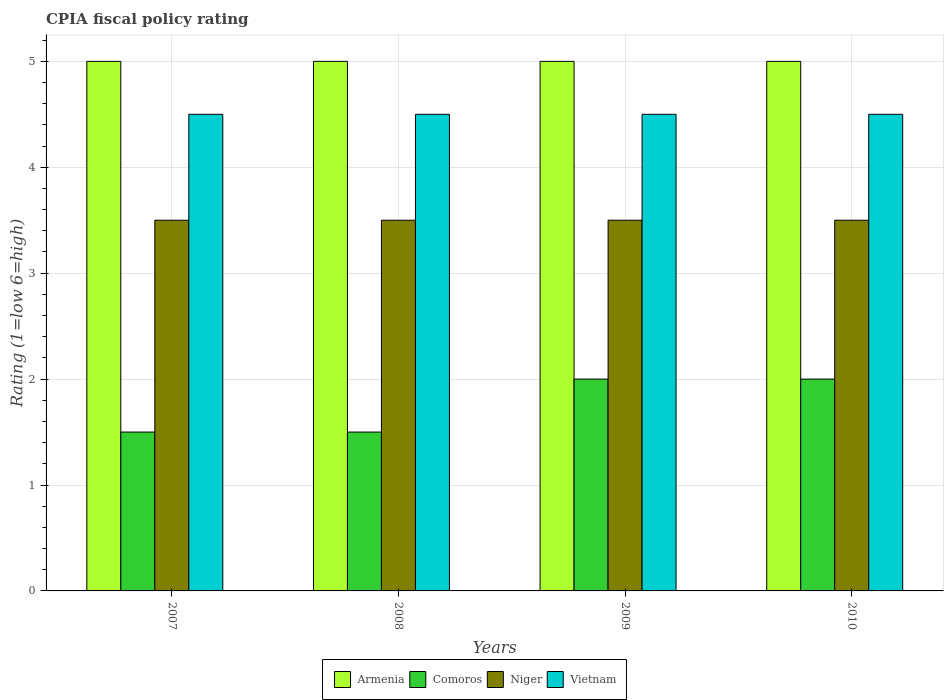Are the number of bars per tick equal to the number of legend labels?
Your answer should be compact. Yes. How many bars are there on the 1st tick from the right?
Provide a succinct answer. 4. What is the label of the 3rd group of bars from the left?
Offer a terse response. 2009. In how many cases, is the number of bars for a given year not equal to the number of legend labels?
Offer a terse response. 0. Across all years, what is the minimum CPIA rating in Niger?
Make the answer very short. 3.5. In which year was the CPIA rating in Niger maximum?
Give a very brief answer. 2007. What is the difference between the CPIA rating in Vietnam in 2007 and that in 2008?
Keep it short and to the point. 0. What is the difference between the CPIA rating in Armenia in 2007 and the CPIA rating in Comoros in 2010?
Keep it short and to the point. 3. In the year 2008, what is the difference between the CPIA rating in Armenia and CPIA rating in Vietnam?
Your answer should be compact. 0.5. In how many years, is the CPIA rating in Vietnam greater than 2.6?
Give a very brief answer. 4. What is the ratio of the CPIA rating in Vietnam in 2009 to that in 2010?
Provide a short and direct response. 1. Is the CPIA rating in Armenia in 2007 less than that in 2010?
Provide a short and direct response. No. Is the difference between the CPIA rating in Armenia in 2007 and 2008 greater than the difference between the CPIA rating in Vietnam in 2007 and 2008?
Offer a terse response. No. What is the difference between the highest and the lowest CPIA rating in Comoros?
Your answer should be very brief. 0.5. In how many years, is the CPIA rating in Armenia greater than the average CPIA rating in Armenia taken over all years?
Provide a short and direct response. 0. Is the sum of the CPIA rating in Niger in 2007 and 2008 greater than the maximum CPIA rating in Armenia across all years?
Your response must be concise. Yes. Is it the case that in every year, the sum of the CPIA rating in Armenia and CPIA rating in Vietnam is greater than the sum of CPIA rating in Comoros and CPIA rating in Niger?
Your answer should be compact. Yes. What does the 1st bar from the left in 2010 represents?
Your response must be concise. Armenia. What does the 3rd bar from the right in 2010 represents?
Give a very brief answer. Comoros. Is it the case that in every year, the sum of the CPIA rating in Vietnam and CPIA rating in Armenia is greater than the CPIA rating in Comoros?
Provide a short and direct response. Yes. How many bars are there?
Give a very brief answer. 16. Are all the bars in the graph horizontal?
Offer a very short reply. No. How many years are there in the graph?
Your response must be concise. 4. What is the difference between two consecutive major ticks on the Y-axis?
Keep it short and to the point. 1. Does the graph contain any zero values?
Your answer should be compact. No. Does the graph contain grids?
Your response must be concise. Yes. How are the legend labels stacked?
Provide a short and direct response. Horizontal. What is the title of the graph?
Your answer should be very brief. CPIA fiscal policy rating. Does "Malta" appear as one of the legend labels in the graph?
Give a very brief answer. No. What is the Rating (1=low 6=high) of Niger in 2007?
Offer a terse response. 3.5. What is the Rating (1=low 6=high) in Niger in 2008?
Make the answer very short. 3.5. What is the Rating (1=low 6=high) in Vietnam in 2008?
Give a very brief answer. 4.5. What is the Rating (1=low 6=high) of Armenia in 2009?
Provide a succinct answer. 5. What is the Rating (1=low 6=high) of Niger in 2009?
Your response must be concise. 3.5. What is the Rating (1=low 6=high) of Armenia in 2010?
Offer a terse response. 5. Across all years, what is the maximum Rating (1=low 6=high) in Armenia?
Give a very brief answer. 5. Across all years, what is the maximum Rating (1=low 6=high) in Vietnam?
Ensure brevity in your answer.  4.5. What is the total Rating (1=low 6=high) of Niger in the graph?
Your answer should be compact. 14. What is the total Rating (1=low 6=high) of Vietnam in the graph?
Your answer should be compact. 18. What is the difference between the Rating (1=low 6=high) in Armenia in 2007 and that in 2008?
Ensure brevity in your answer.  0. What is the difference between the Rating (1=low 6=high) in Armenia in 2007 and that in 2009?
Your answer should be very brief. 0. What is the difference between the Rating (1=low 6=high) of Comoros in 2007 and that in 2010?
Provide a short and direct response. -0.5. What is the difference between the Rating (1=low 6=high) of Vietnam in 2007 and that in 2010?
Provide a short and direct response. 0. What is the difference between the Rating (1=low 6=high) of Comoros in 2008 and that in 2009?
Make the answer very short. -0.5. What is the difference between the Rating (1=low 6=high) of Niger in 2008 and that in 2009?
Make the answer very short. 0. What is the difference between the Rating (1=low 6=high) of Vietnam in 2008 and that in 2009?
Provide a succinct answer. 0. What is the difference between the Rating (1=low 6=high) of Armenia in 2008 and that in 2010?
Offer a terse response. 0. What is the difference between the Rating (1=low 6=high) in Niger in 2008 and that in 2010?
Give a very brief answer. 0. What is the difference between the Rating (1=low 6=high) of Comoros in 2009 and that in 2010?
Your answer should be very brief. 0. What is the difference between the Rating (1=low 6=high) in Niger in 2009 and that in 2010?
Ensure brevity in your answer.  0. What is the difference between the Rating (1=low 6=high) of Vietnam in 2009 and that in 2010?
Provide a short and direct response. 0. What is the difference between the Rating (1=low 6=high) of Armenia in 2007 and the Rating (1=low 6=high) of Comoros in 2008?
Give a very brief answer. 3.5. What is the difference between the Rating (1=low 6=high) in Armenia in 2007 and the Rating (1=low 6=high) in Vietnam in 2008?
Provide a short and direct response. 0.5. What is the difference between the Rating (1=low 6=high) of Comoros in 2007 and the Rating (1=low 6=high) of Niger in 2008?
Provide a succinct answer. -2. What is the difference between the Rating (1=low 6=high) in Comoros in 2007 and the Rating (1=low 6=high) in Vietnam in 2008?
Offer a very short reply. -3. What is the difference between the Rating (1=low 6=high) of Armenia in 2007 and the Rating (1=low 6=high) of Vietnam in 2009?
Your response must be concise. 0.5. What is the difference between the Rating (1=low 6=high) of Comoros in 2007 and the Rating (1=low 6=high) of Vietnam in 2009?
Ensure brevity in your answer.  -3. What is the difference between the Rating (1=low 6=high) of Armenia in 2007 and the Rating (1=low 6=high) of Comoros in 2010?
Ensure brevity in your answer.  3. What is the difference between the Rating (1=low 6=high) in Comoros in 2007 and the Rating (1=low 6=high) in Niger in 2010?
Keep it short and to the point. -2. What is the difference between the Rating (1=low 6=high) of Armenia in 2008 and the Rating (1=low 6=high) of Comoros in 2009?
Provide a succinct answer. 3. What is the difference between the Rating (1=low 6=high) of Niger in 2008 and the Rating (1=low 6=high) of Vietnam in 2009?
Your response must be concise. -1. What is the difference between the Rating (1=low 6=high) of Comoros in 2008 and the Rating (1=low 6=high) of Niger in 2010?
Give a very brief answer. -2. What is the difference between the Rating (1=low 6=high) in Niger in 2008 and the Rating (1=low 6=high) in Vietnam in 2010?
Your response must be concise. -1. What is the difference between the Rating (1=low 6=high) of Armenia in 2009 and the Rating (1=low 6=high) of Niger in 2010?
Your answer should be very brief. 1.5. What is the difference between the Rating (1=low 6=high) of Armenia in 2009 and the Rating (1=low 6=high) of Vietnam in 2010?
Your answer should be compact. 0.5. What is the difference between the Rating (1=low 6=high) in Comoros in 2009 and the Rating (1=low 6=high) in Niger in 2010?
Your response must be concise. -1.5. What is the difference between the Rating (1=low 6=high) of Comoros in 2009 and the Rating (1=low 6=high) of Vietnam in 2010?
Your answer should be compact. -2.5. What is the average Rating (1=low 6=high) in Armenia per year?
Your answer should be compact. 5. In the year 2007, what is the difference between the Rating (1=low 6=high) of Armenia and Rating (1=low 6=high) of Niger?
Provide a short and direct response. 1.5. In the year 2007, what is the difference between the Rating (1=low 6=high) of Comoros and Rating (1=low 6=high) of Niger?
Give a very brief answer. -2. In the year 2007, what is the difference between the Rating (1=low 6=high) of Comoros and Rating (1=low 6=high) of Vietnam?
Ensure brevity in your answer.  -3. In the year 2007, what is the difference between the Rating (1=low 6=high) of Niger and Rating (1=low 6=high) of Vietnam?
Ensure brevity in your answer.  -1. In the year 2008, what is the difference between the Rating (1=low 6=high) in Armenia and Rating (1=low 6=high) in Comoros?
Your response must be concise. 3.5. In the year 2008, what is the difference between the Rating (1=low 6=high) in Armenia and Rating (1=low 6=high) in Vietnam?
Provide a succinct answer. 0.5. In the year 2008, what is the difference between the Rating (1=low 6=high) of Comoros and Rating (1=low 6=high) of Niger?
Ensure brevity in your answer.  -2. In the year 2008, what is the difference between the Rating (1=low 6=high) in Comoros and Rating (1=low 6=high) in Vietnam?
Offer a very short reply. -3. In the year 2008, what is the difference between the Rating (1=low 6=high) in Niger and Rating (1=low 6=high) in Vietnam?
Provide a short and direct response. -1. In the year 2009, what is the difference between the Rating (1=low 6=high) in Armenia and Rating (1=low 6=high) in Comoros?
Offer a very short reply. 3. In the year 2009, what is the difference between the Rating (1=low 6=high) in Comoros and Rating (1=low 6=high) in Niger?
Provide a short and direct response. -1.5. In the year 2010, what is the difference between the Rating (1=low 6=high) in Armenia and Rating (1=low 6=high) in Niger?
Offer a very short reply. 1.5. In the year 2010, what is the difference between the Rating (1=low 6=high) in Comoros and Rating (1=low 6=high) in Niger?
Your answer should be very brief. -1.5. In the year 2010, what is the difference between the Rating (1=low 6=high) in Niger and Rating (1=low 6=high) in Vietnam?
Provide a short and direct response. -1. What is the ratio of the Rating (1=low 6=high) of Armenia in 2007 to that in 2008?
Your answer should be compact. 1. What is the ratio of the Rating (1=low 6=high) of Vietnam in 2007 to that in 2008?
Provide a short and direct response. 1. What is the ratio of the Rating (1=low 6=high) in Armenia in 2007 to that in 2009?
Provide a succinct answer. 1. What is the ratio of the Rating (1=low 6=high) of Comoros in 2007 to that in 2009?
Your response must be concise. 0.75. What is the ratio of the Rating (1=low 6=high) of Vietnam in 2007 to that in 2009?
Your response must be concise. 1. What is the ratio of the Rating (1=low 6=high) in Armenia in 2007 to that in 2010?
Offer a terse response. 1. What is the ratio of the Rating (1=low 6=high) of Comoros in 2007 to that in 2010?
Provide a succinct answer. 0.75. What is the ratio of the Rating (1=low 6=high) of Niger in 2007 to that in 2010?
Give a very brief answer. 1. What is the ratio of the Rating (1=low 6=high) of Niger in 2008 to that in 2009?
Provide a succinct answer. 1. What is the ratio of the Rating (1=low 6=high) in Vietnam in 2008 to that in 2009?
Your answer should be compact. 1. What is the ratio of the Rating (1=low 6=high) of Comoros in 2008 to that in 2010?
Ensure brevity in your answer.  0.75. What is the ratio of the Rating (1=low 6=high) in Niger in 2009 to that in 2010?
Give a very brief answer. 1. What is the difference between the highest and the second highest Rating (1=low 6=high) of Armenia?
Make the answer very short. 0. What is the difference between the highest and the second highest Rating (1=low 6=high) of Comoros?
Ensure brevity in your answer.  0. What is the difference between the highest and the second highest Rating (1=low 6=high) of Niger?
Provide a short and direct response. 0. What is the difference between the highest and the lowest Rating (1=low 6=high) of Armenia?
Ensure brevity in your answer.  0. What is the difference between the highest and the lowest Rating (1=low 6=high) of Niger?
Make the answer very short. 0. 